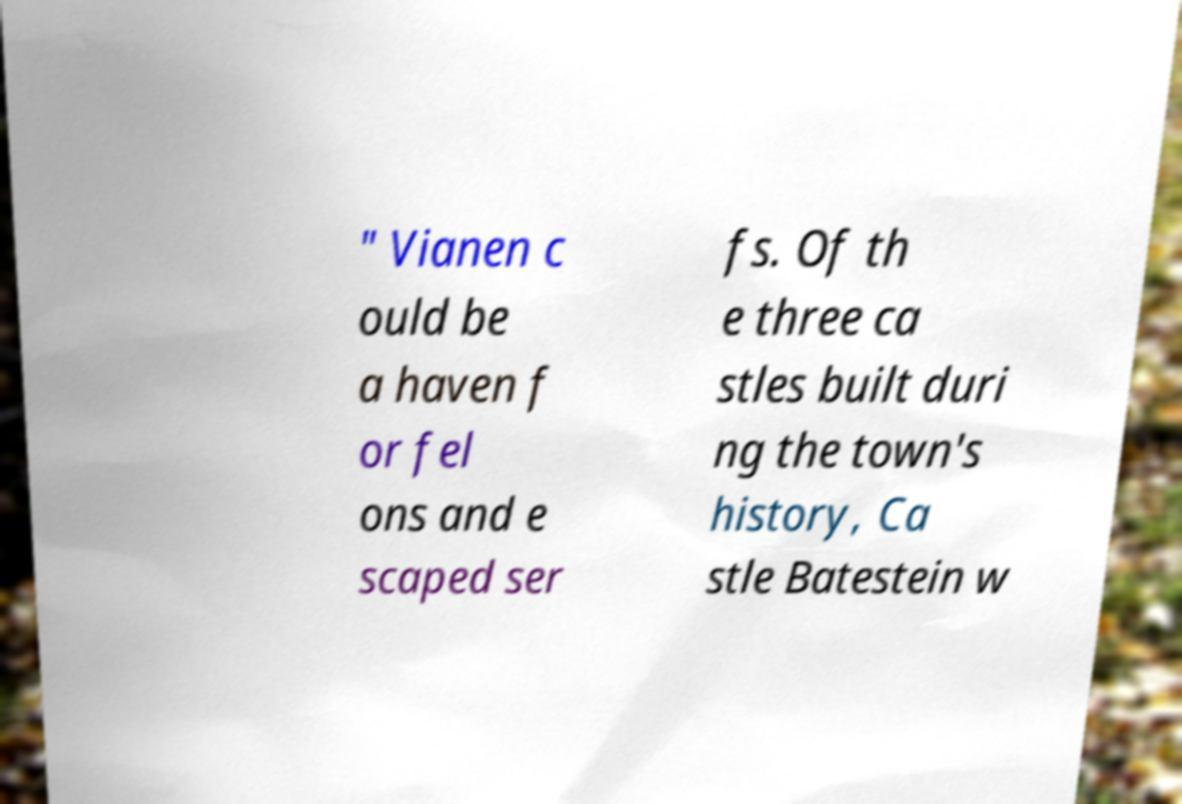Could you extract and type out the text from this image? " Vianen c ould be a haven f or fel ons and e scaped ser fs. Of th e three ca stles built duri ng the town's history, Ca stle Batestein w 